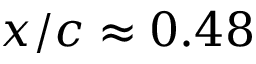<formula> <loc_0><loc_0><loc_500><loc_500>x / c \approx 0 . 4 8</formula> 